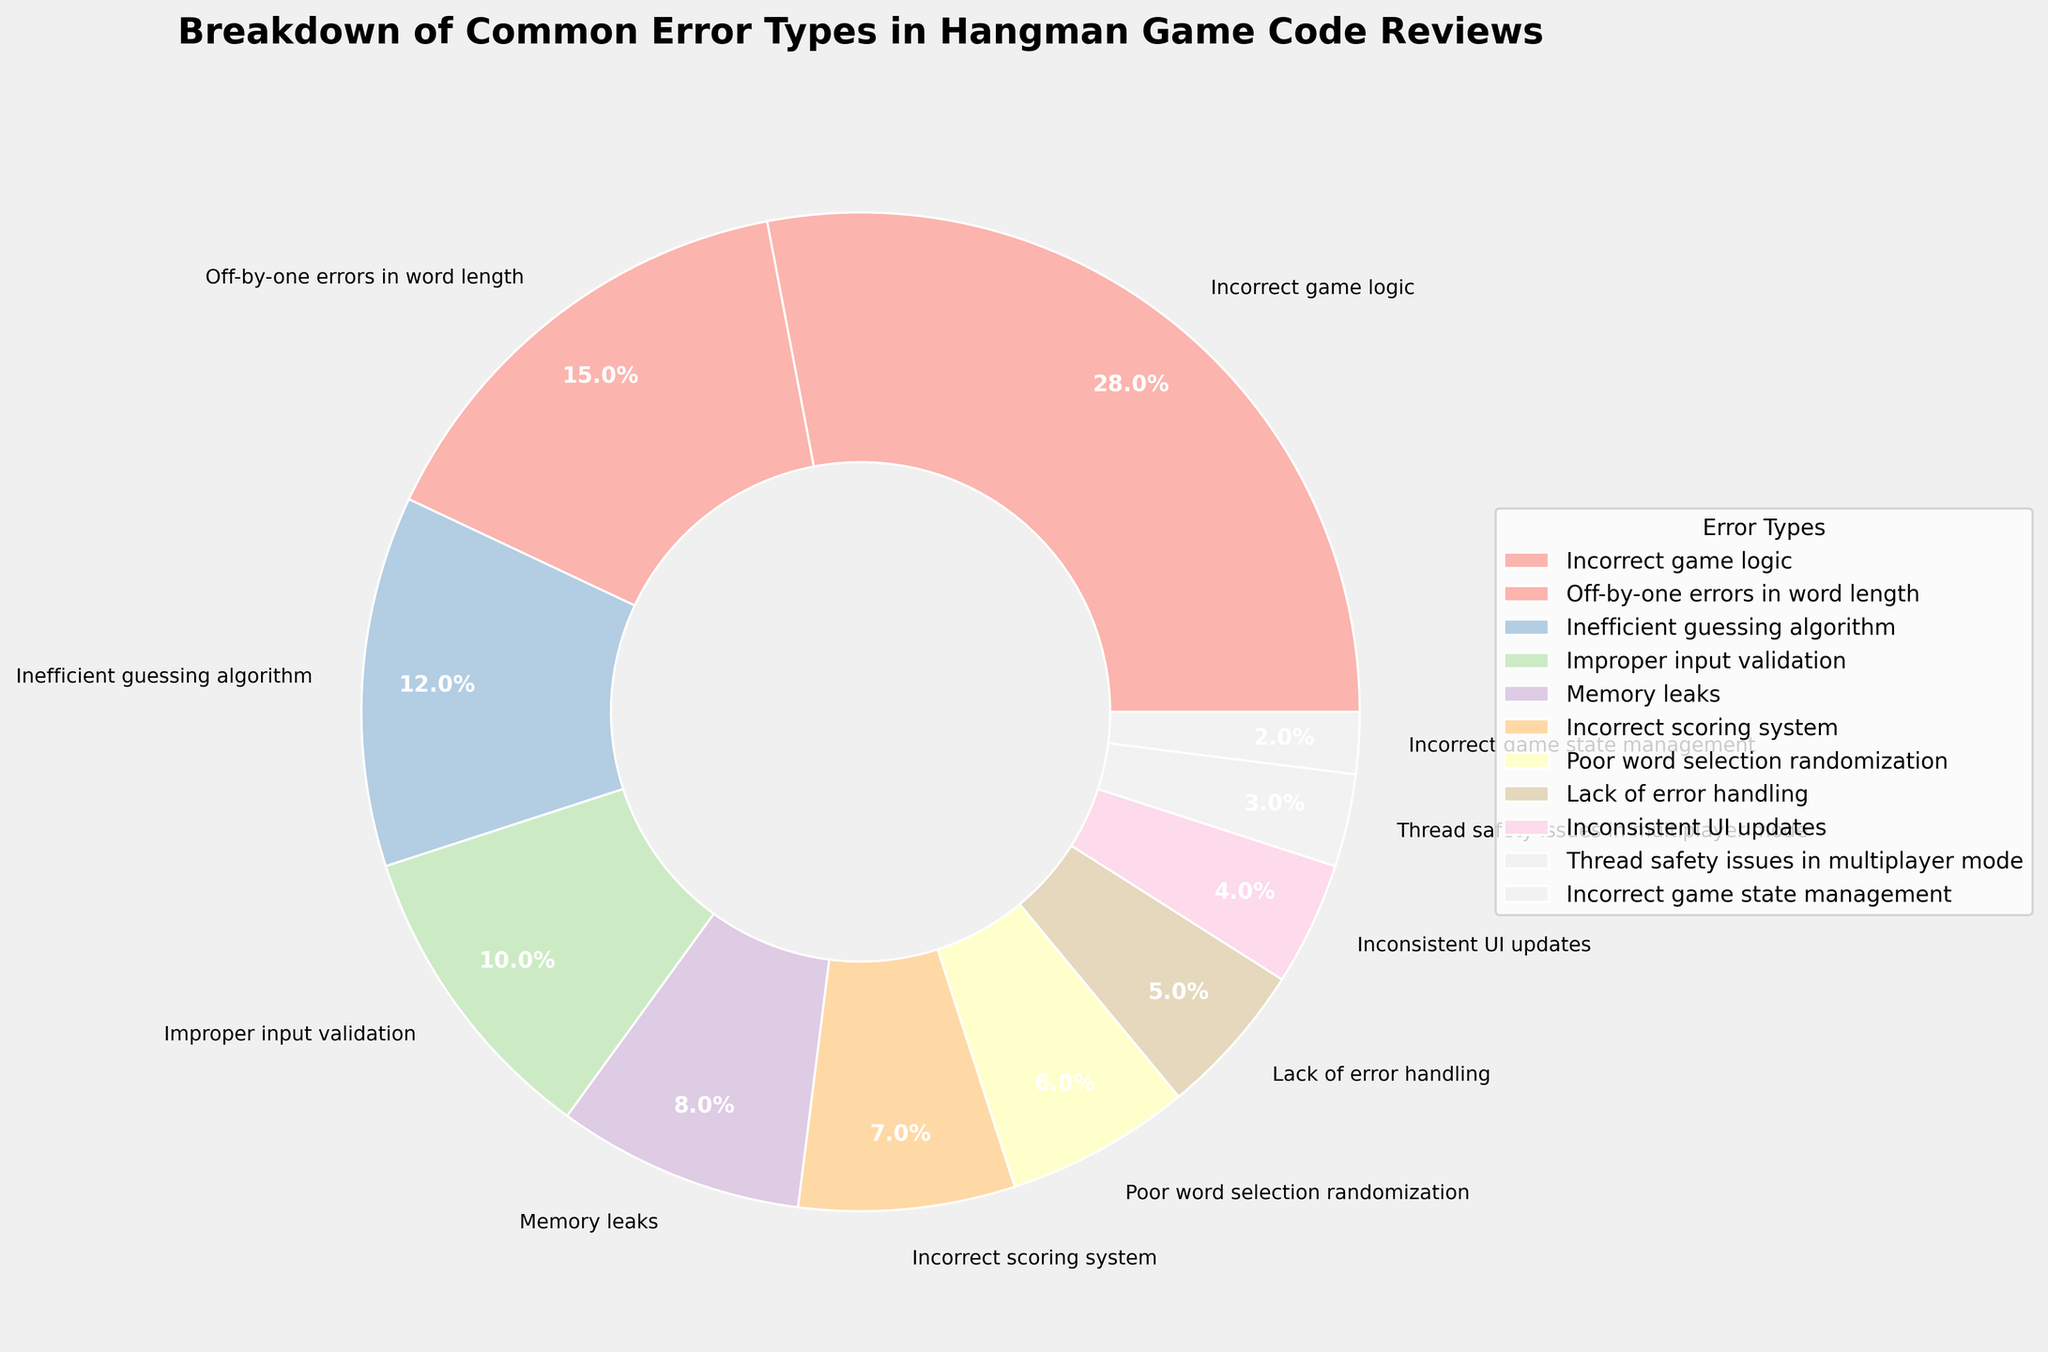Which error type has the highest percentage? Look at the segment with the largest area in the pie chart and identify the label. "Incorrect game logic" shows the largest segment.
Answer: Incorrect game logic What is the combined percentage of 'Memory leaks' and 'Improper input validation'? Add the percentages for 'Memory leaks' (8) and 'Improper input validation' (10). 8 + 10 = 18.
Answer: 18% How much smaller is the percentage of 'Poor word selection randomization' compared to 'Off-by-one errors in word length'? Subtract the percentage of 'Poor word selection randomization' (6) from 'Off-by-one errors in word length' (15). 15 - 6 = 9.
Answer: 9% Which error type shows the smallest percentage, and what is it? Look for the smallest segment in the pie chart and identify the label. "Incorrect game state management" is the smallest segment, showing 2%.
Answer: Incorrect game state management, 2% Are there more percentage points allocated to 'Inefficient guessing algorithm' or 'Incorrect scoring system'? Compare the percentage values: 'Inefficient guessing algorithm' has 12%, while 'Incorrect scoring system' has 7%. 12 is greater than 7.
Answer: Inefficient guessing algorithm What is the sum of percentages for 'Thread safety issues in multiplayer mode' and 'Lack of error handling'? Add the percentages for 'Thread safety issues in multiplayer mode' (3) and 'Lack of error handling' (5). 3 + 5 = 8.
Answer: 8% Which error type is represented by the fourth-largest segment and what is its percentage? Identify and rank the four largest segments: 1. Incorrect game logic (28%), 2. Off-by-one errors in word length (15%), 3. Inefficient guessing algorithm (12%), 4. Improper input validation (10%).
Answer: Improper input validation, 10% Which two error types combined amount to exactly 20%? Locate the error types where their sum equals 20: 'Memory leaks' (8%) and 'Improper input validation' (10%) do not sum to 20, but 'Poor word selection randomization' (6%) and 'Incorrect scoring system' (7%) sum to 13. Continue until the pair 'Memory leaks' (8%) and 'Off-by-one errors in word length' (15%) sum to exactly 20.
Answer: None What is the difference in percentage between 'Inconsistent UI updates' and 'Incorrect game state management'? Subtract the percentage of 'Incorrect game state management' (2) from 'Inconsistent UI updates' (4). 4 - 2 = 2.
Answer: 2% Which error types together make up more than 30% of the pie chart? Look for the segments that, when combined, exceed 30%. 'Incorrect game logic' (28%) and 'Off-by-one errors in word length' (15%) together make 43%. 28 + 15 = 43.
Answer: Incorrect game logic and Off-by-one errors in word length 